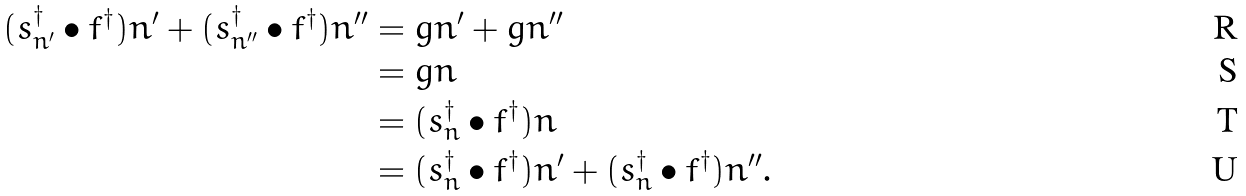Convert formula to latex. <formula><loc_0><loc_0><loc_500><loc_500>( s _ { n ^ { \prime } } ^ { \dag } \bullet f ^ { \dag } ) n ^ { \prime } + ( s _ { n ^ { \prime \prime } } ^ { \dag } \bullet f ^ { \dag } ) n ^ { \prime \prime } & = g n ^ { \prime } + g n ^ { \prime \prime } \\ & = g n \\ & = ( s _ { n } ^ { \dag } \bullet f ^ { \dag } ) n \\ & = ( s _ { n } ^ { \dag } \bullet f ^ { \dag } ) n ^ { \prime } + ( s _ { n } ^ { \dag } \bullet f ^ { \dag } ) n ^ { \prime \prime } .</formula> 